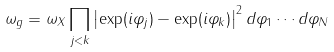<formula> <loc_0><loc_0><loc_500><loc_500>\omega _ { g } = \omega _ { X } \prod _ { j < k } \left | \exp ( i \varphi _ { j } ) - \exp ( i \varphi _ { k } ) \right | ^ { 2 } d \varphi _ { 1 } \cdots d \varphi _ { N }</formula> 